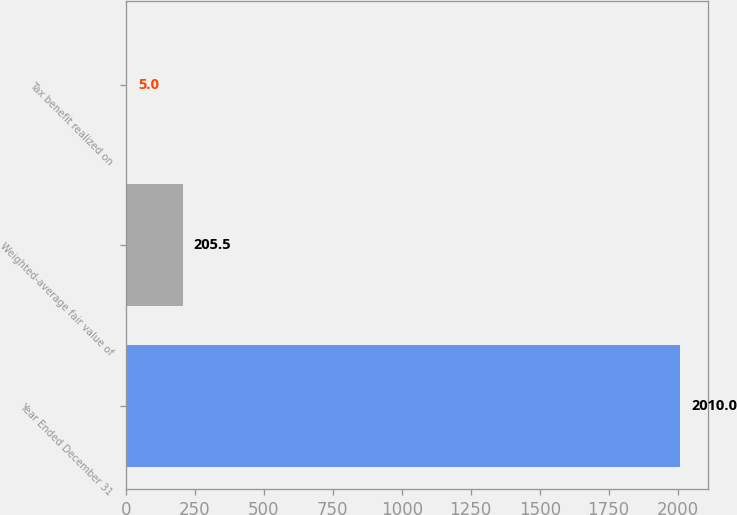Convert chart. <chart><loc_0><loc_0><loc_500><loc_500><bar_chart><fcel>Year Ended December 31<fcel>Weighted-average fair value of<fcel>Tax benefit realized on<nl><fcel>2010<fcel>205.5<fcel>5<nl></chart> 